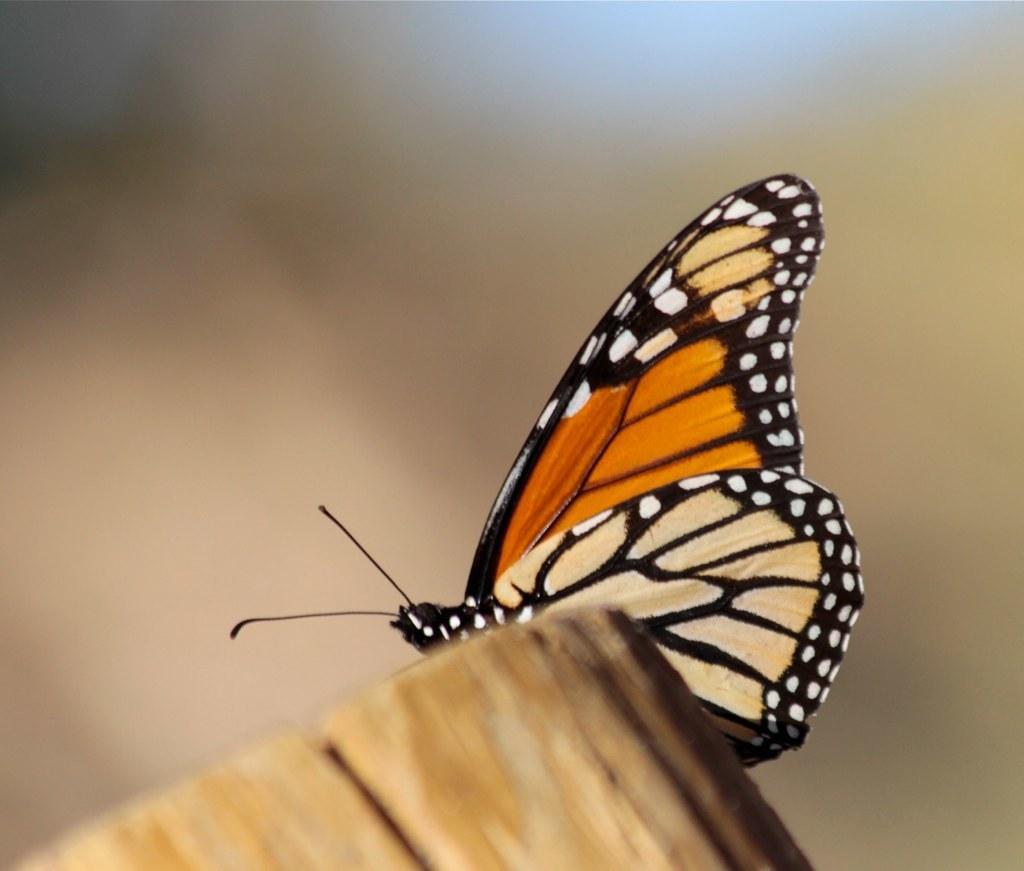Please provide a concise description of this image. In the center of the image we can see a butterfly on the wooden log. 